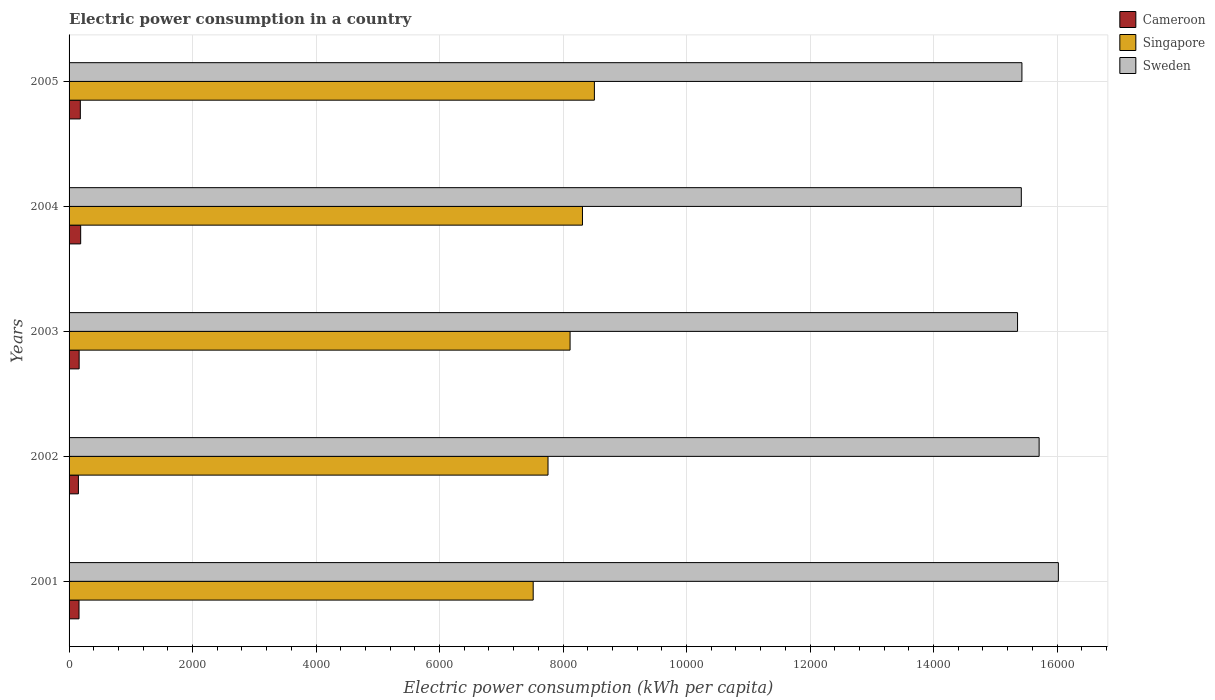Are the number of bars on each tick of the Y-axis equal?
Keep it short and to the point. Yes. How many bars are there on the 3rd tick from the top?
Keep it short and to the point. 3. How many bars are there on the 3rd tick from the bottom?
Keep it short and to the point. 3. What is the label of the 4th group of bars from the top?
Your answer should be compact. 2002. What is the electric power consumption in in Singapore in 2002?
Provide a short and direct response. 7756.23. Across all years, what is the maximum electric power consumption in in Singapore?
Ensure brevity in your answer.  8507.2. Across all years, what is the minimum electric power consumption in in Cameroon?
Ensure brevity in your answer.  151.14. In which year was the electric power consumption in in Cameroon maximum?
Keep it short and to the point. 2004. In which year was the electric power consumption in in Cameroon minimum?
Keep it short and to the point. 2002. What is the total electric power consumption in in Cameroon in the graph?
Provide a succinct answer. 845.44. What is the difference between the electric power consumption in in Sweden in 2004 and that in 2005?
Ensure brevity in your answer.  -9.99. What is the difference between the electric power consumption in in Cameroon in 2001 and the electric power consumption in in Sweden in 2002?
Your answer should be very brief. -1.55e+04. What is the average electric power consumption in in Cameroon per year?
Ensure brevity in your answer.  169.09. In the year 2005, what is the difference between the electric power consumption in in Singapore and electric power consumption in in Sweden?
Ensure brevity in your answer.  -6923.77. In how many years, is the electric power consumption in in Singapore greater than 12000 kWh per capita?
Keep it short and to the point. 0. What is the ratio of the electric power consumption in in Cameroon in 2001 to that in 2005?
Give a very brief answer. 0.88. Is the electric power consumption in in Singapore in 2001 less than that in 2004?
Offer a very short reply. Yes. What is the difference between the highest and the second highest electric power consumption in in Singapore?
Ensure brevity in your answer.  192.94. What is the difference between the highest and the lowest electric power consumption in in Sweden?
Your answer should be compact. 660.8. In how many years, is the electric power consumption in in Singapore greater than the average electric power consumption in in Singapore taken over all years?
Make the answer very short. 3. Is the sum of the electric power consumption in in Sweden in 2002 and 2005 greater than the maximum electric power consumption in in Singapore across all years?
Your answer should be compact. Yes. What does the 2nd bar from the top in 2001 represents?
Your response must be concise. Singapore. What does the 1st bar from the bottom in 2004 represents?
Offer a very short reply. Cameroon. Are all the bars in the graph horizontal?
Provide a short and direct response. Yes. How many years are there in the graph?
Keep it short and to the point. 5. What is the difference between two consecutive major ticks on the X-axis?
Make the answer very short. 2000. Are the values on the major ticks of X-axis written in scientific E-notation?
Offer a very short reply. No. Does the graph contain grids?
Your response must be concise. Yes. What is the title of the graph?
Ensure brevity in your answer.  Electric power consumption in a country. What is the label or title of the X-axis?
Keep it short and to the point. Electric power consumption (kWh per capita). What is the label or title of the Y-axis?
Your response must be concise. Years. What is the Electric power consumption (kWh per capita) in Cameroon in 2001?
Your response must be concise. 160.92. What is the Electric power consumption (kWh per capita) in Singapore in 2001?
Your answer should be compact. 7516.19. What is the Electric power consumption (kWh per capita) in Sweden in 2001?
Provide a succinct answer. 1.60e+04. What is the Electric power consumption (kWh per capita) of Cameroon in 2002?
Give a very brief answer. 151.14. What is the Electric power consumption (kWh per capita) of Singapore in 2002?
Offer a terse response. 7756.23. What is the Electric power consumption (kWh per capita) of Sweden in 2002?
Ensure brevity in your answer.  1.57e+04. What is the Electric power consumption (kWh per capita) of Cameroon in 2003?
Your answer should be compact. 163.08. What is the Electric power consumption (kWh per capita) of Singapore in 2003?
Provide a short and direct response. 8113.64. What is the Electric power consumption (kWh per capita) in Sweden in 2003?
Your answer should be compact. 1.54e+04. What is the Electric power consumption (kWh per capita) of Cameroon in 2004?
Give a very brief answer. 187.91. What is the Electric power consumption (kWh per capita) in Singapore in 2004?
Keep it short and to the point. 8314.25. What is the Electric power consumption (kWh per capita) of Sweden in 2004?
Your answer should be very brief. 1.54e+04. What is the Electric power consumption (kWh per capita) in Cameroon in 2005?
Provide a short and direct response. 182.38. What is the Electric power consumption (kWh per capita) in Singapore in 2005?
Your response must be concise. 8507.2. What is the Electric power consumption (kWh per capita) of Sweden in 2005?
Provide a short and direct response. 1.54e+04. Across all years, what is the maximum Electric power consumption (kWh per capita) of Cameroon?
Your response must be concise. 187.91. Across all years, what is the maximum Electric power consumption (kWh per capita) of Singapore?
Your answer should be very brief. 8507.2. Across all years, what is the maximum Electric power consumption (kWh per capita) in Sweden?
Provide a short and direct response. 1.60e+04. Across all years, what is the minimum Electric power consumption (kWh per capita) of Cameroon?
Make the answer very short. 151.14. Across all years, what is the minimum Electric power consumption (kWh per capita) in Singapore?
Keep it short and to the point. 7516.19. Across all years, what is the minimum Electric power consumption (kWh per capita) in Sweden?
Give a very brief answer. 1.54e+04. What is the total Electric power consumption (kWh per capita) in Cameroon in the graph?
Your answer should be compact. 845.44. What is the total Electric power consumption (kWh per capita) of Singapore in the graph?
Give a very brief answer. 4.02e+04. What is the total Electric power consumption (kWh per capita) of Sweden in the graph?
Offer a terse response. 7.79e+04. What is the difference between the Electric power consumption (kWh per capita) of Cameroon in 2001 and that in 2002?
Provide a succinct answer. 9.79. What is the difference between the Electric power consumption (kWh per capita) of Singapore in 2001 and that in 2002?
Your answer should be very brief. -240.03. What is the difference between the Electric power consumption (kWh per capita) in Sweden in 2001 and that in 2002?
Your answer should be very brief. 311.55. What is the difference between the Electric power consumption (kWh per capita) of Cameroon in 2001 and that in 2003?
Make the answer very short. -2.16. What is the difference between the Electric power consumption (kWh per capita) of Singapore in 2001 and that in 2003?
Offer a terse response. -597.45. What is the difference between the Electric power consumption (kWh per capita) of Sweden in 2001 and that in 2003?
Make the answer very short. 660.8. What is the difference between the Electric power consumption (kWh per capita) in Cameroon in 2001 and that in 2004?
Offer a very short reply. -26.99. What is the difference between the Electric power consumption (kWh per capita) in Singapore in 2001 and that in 2004?
Provide a short and direct response. -798.06. What is the difference between the Electric power consumption (kWh per capita) of Sweden in 2001 and that in 2004?
Give a very brief answer. 600.01. What is the difference between the Electric power consumption (kWh per capita) of Cameroon in 2001 and that in 2005?
Offer a very short reply. -21.46. What is the difference between the Electric power consumption (kWh per capita) of Singapore in 2001 and that in 2005?
Keep it short and to the point. -991.01. What is the difference between the Electric power consumption (kWh per capita) of Sweden in 2001 and that in 2005?
Provide a succinct answer. 590.02. What is the difference between the Electric power consumption (kWh per capita) of Cameroon in 2002 and that in 2003?
Your answer should be very brief. -11.94. What is the difference between the Electric power consumption (kWh per capita) in Singapore in 2002 and that in 2003?
Provide a succinct answer. -357.41. What is the difference between the Electric power consumption (kWh per capita) in Sweden in 2002 and that in 2003?
Your answer should be compact. 349.25. What is the difference between the Electric power consumption (kWh per capita) in Cameroon in 2002 and that in 2004?
Offer a terse response. -36.78. What is the difference between the Electric power consumption (kWh per capita) in Singapore in 2002 and that in 2004?
Give a very brief answer. -558.03. What is the difference between the Electric power consumption (kWh per capita) in Sweden in 2002 and that in 2004?
Your response must be concise. 288.46. What is the difference between the Electric power consumption (kWh per capita) in Cameroon in 2002 and that in 2005?
Keep it short and to the point. -31.24. What is the difference between the Electric power consumption (kWh per capita) in Singapore in 2002 and that in 2005?
Your answer should be compact. -750.97. What is the difference between the Electric power consumption (kWh per capita) in Sweden in 2002 and that in 2005?
Give a very brief answer. 278.47. What is the difference between the Electric power consumption (kWh per capita) in Cameroon in 2003 and that in 2004?
Your response must be concise. -24.84. What is the difference between the Electric power consumption (kWh per capita) of Singapore in 2003 and that in 2004?
Your answer should be very brief. -200.61. What is the difference between the Electric power consumption (kWh per capita) in Sweden in 2003 and that in 2004?
Your response must be concise. -60.79. What is the difference between the Electric power consumption (kWh per capita) in Cameroon in 2003 and that in 2005?
Provide a short and direct response. -19.3. What is the difference between the Electric power consumption (kWh per capita) of Singapore in 2003 and that in 2005?
Give a very brief answer. -393.56. What is the difference between the Electric power consumption (kWh per capita) of Sweden in 2003 and that in 2005?
Your answer should be compact. -70.79. What is the difference between the Electric power consumption (kWh per capita) in Cameroon in 2004 and that in 2005?
Ensure brevity in your answer.  5.54. What is the difference between the Electric power consumption (kWh per capita) in Singapore in 2004 and that in 2005?
Give a very brief answer. -192.94. What is the difference between the Electric power consumption (kWh per capita) in Sweden in 2004 and that in 2005?
Provide a short and direct response. -9.99. What is the difference between the Electric power consumption (kWh per capita) of Cameroon in 2001 and the Electric power consumption (kWh per capita) of Singapore in 2002?
Provide a short and direct response. -7595.3. What is the difference between the Electric power consumption (kWh per capita) of Cameroon in 2001 and the Electric power consumption (kWh per capita) of Sweden in 2002?
Your answer should be compact. -1.55e+04. What is the difference between the Electric power consumption (kWh per capita) in Singapore in 2001 and the Electric power consumption (kWh per capita) in Sweden in 2002?
Provide a short and direct response. -8193.24. What is the difference between the Electric power consumption (kWh per capita) of Cameroon in 2001 and the Electric power consumption (kWh per capita) of Singapore in 2003?
Your response must be concise. -7952.71. What is the difference between the Electric power consumption (kWh per capita) in Cameroon in 2001 and the Electric power consumption (kWh per capita) in Sweden in 2003?
Give a very brief answer. -1.52e+04. What is the difference between the Electric power consumption (kWh per capita) in Singapore in 2001 and the Electric power consumption (kWh per capita) in Sweden in 2003?
Offer a terse response. -7843.99. What is the difference between the Electric power consumption (kWh per capita) of Cameroon in 2001 and the Electric power consumption (kWh per capita) of Singapore in 2004?
Give a very brief answer. -8153.33. What is the difference between the Electric power consumption (kWh per capita) of Cameroon in 2001 and the Electric power consumption (kWh per capita) of Sweden in 2004?
Give a very brief answer. -1.53e+04. What is the difference between the Electric power consumption (kWh per capita) of Singapore in 2001 and the Electric power consumption (kWh per capita) of Sweden in 2004?
Give a very brief answer. -7904.78. What is the difference between the Electric power consumption (kWh per capita) in Cameroon in 2001 and the Electric power consumption (kWh per capita) in Singapore in 2005?
Keep it short and to the point. -8346.27. What is the difference between the Electric power consumption (kWh per capita) in Cameroon in 2001 and the Electric power consumption (kWh per capita) in Sweden in 2005?
Make the answer very short. -1.53e+04. What is the difference between the Electric power consumption (kWh per capita) of Singapore in 2001 and the Electric power consumption (kWh per capita) of Sweden in 2005?
Your answer should be very brief. -7914.77. What is the difference between the Electric power consumption (kWh per capita) of Cameroon in 2002 and the Electric power consumption (kWh per capita) of Singapore in 2003?
Provide a succinct answer. -7962.5. What is the difference between the Electric power consumption (kWh per capita) in Cameroon in 2002 and the Electric power consumption (kWh per capita) in Sweden in 2003?
Provide a succinct answer. -1.52e+04. What is the difference between the Electric power consumption (kWh per capita) of Singapore in 2002 and the Electric power consumption (kWh per capita) of Sweden in 2003?
Give a very brief answer. -7603.95. What is the difference between the Electric power consumption (kWh per capita) in Cameroon in 2002 and the Electric power consumption (kWh per capita) in Singapore in 2004?
Make the answer very short. -8163.12. What is the difference between the Electric power consumption (kWh per capita) of Cameroon in 2002 and the Electric power consumption (kWh per capita) of Sweden in 2004?
Offer a very short reply. -1.53e+04. What is the difference between the Electric power consumption (kWh per capita) in Singapore in 2002 and the Electric power consumption (kWh per capita) in Sweden in 2004?
Your response must be concise. -7664.75. What is the difference between the Electric power consumption (kWh per capita) of Cameroon in 2002 and the Electric power consumption (kWh per capita) of Singapore in 2005?
Your answer should be very brief. -8356.06. What is the difference between the Electric power consumption (kWh per capita) of Cameroon in 2002 and the Electric power consumption (kWh per capita) of Sweden in 2005?
Offer a very short reply. -1.53e+04. What is the difference between the Electric power consumption (kWh per capita) of Singapore in 2002 and the Electric power consumption (kWh per capita) of Sweden in 2005?
Give a very brief answer. -7674.74. What is the difference between the Electric power consumption (kWh per capita) of Cameroon in 2003 and the Electric power consumption (kWh per capita) of Singapore in 2004?
Your answer should be very brief. -8151.17. What is the difference between the Electric power consumption (kWh per capita) in Cameroon in 2003 and the Electric power consumption (kWh per capita) in Sweden in 2004?
Your response must be concise. -1.53e+04. What is the difference between the Electric power consumption (kWh per capita) of Singapore in 2003 and the Electric power consumption (kWh per capita) of Sweden in 2004?
Offer a very short reply. -7307.33. What is the difference between the Electric power consumption (kWh per capita) in Cameroon in 2003 and the Electric power consumption (kWh per capita) in Singapore in 2005?
Your response must be concise. -8344.12. What is the difference between the Electric power consumption (kWh per capita) of Cameroon in 2003 and the Electric power consumption (kWh per capita) of Sweden in 2005?
Ensure brevity in your answer.  -1.53e+04. What is the difference between the Electric power consumption (kWh per capita) in Singapore in 2003 and the Electric power consumption (kWh per capita) in Sweden in 2005?
Offer a terse response. -7317.33. What is the difference between the Electric power consumption (kWh per capita) of Cameroon in 2004 and the Electric power consumption (kWh per capita) of Singapore in 2005?
Keep it short and to the point. -8319.28. What is the difference between the Electric power consumption (kWh per capita) in Cameroon in 2004 and the Electric power consumption (kWh per capita) in Sweden in 2005?
Provide a short and direct response. -1.52e+04. What is the difference between the Electric power consumption (kWh per capita) of Singapore in 2004 and the Electric power consumption (kWh per capita) of Sweden in 2005?
Keep it short and to the point. -7116.71. What is the average Electric power consumption (kWh per capita) of Cameroon per year?
Provide a short and direct response. 169.09. What is the average Electric power consumption (kWh per capita) in Singapore per year?
Give a very brief answer. 8041.5. What is the average Electric power consumption (kWh per capita) of Sweden per year?
Provide a succinct answer. 1.56e+04. In the year 2001, what is the difference between the Electric power consumption (kWh per capita) of Cameroon and Electric power consumption (kWh per capita) of Singapore?
Provide a succinct answer. -7355.27. In the year 2001, what is the difference between the Electric power consumption (kWh per capita) in Cameroon and Electric power consumption (kWh per capita) in Sweden?
Provide a succinct answer. -1.59e+04. In the year 2001, what is the difference between the Electric power consumption (kWh per capita) of Singapore and Electric power consumption (kWh per capita) of Sweden?
Give a very brief answer. -8504.79. In the year 2002, what is the difference between the Electric power consumption (kWh per capita) of Cameroon and Electric power consumption (kWh per capita) of Singapore?
Your answer should be very brief. -7605.09. In the year 2002, what is the difference between the Electric power consumption (kWh per capita) in Cameroon and Electric power consumption (kWh per capita) in Sweden?
Give a very brief answer. -1.56e+04. In the year 2002, what is the difference between the Electric power consumption (kWh per capita) of Singapore and Electric power consumption (kWh per capita) of Sweden?
Your answer should be very brief. -7953.2. In the year 2003, what is the difference between the Electric power consumption (kWh per capita) in Cameroon and Electric power consumption (kWh per capita) in Singapore?
Your answer should be compact. -7950.56. In the year 2003, what is the difference between the Electric power consumption (kWh per capita) of Cameroon and Electric power consumption (kWh per capita) of Sweden?
Your answer should be very brief. -1.52e+04. In the year 2003, what is the difference between the Electric power consumption (kWh per capita) in Singapore and Electric power consumption (kWh per capita) in Sweden?
Provide a succinct answer. -7246.54. In the year 2004, what is the difference between the Electric power consumption (kWh per capita) in Cameroon and Electric power consumption (kWh per capita) in Singapore?
Keep it short and to the point. -8126.34. In the year 2004, what is the difference between the Electric power consumption (kWh per capita) of Cameroon and Electric power consumption (kWh per capita) of Sweden?
Make the answer very short. -1.52e+04. In the year 2004, what is the difference between the Electric power consumption (kWh per capita) in Singapore and Electric power consumption (kWh per capita) in Sweden?
Keep it short and to the point. -7106.72. In the year 2005, what is the difference between the Electric power consumption (kWh per capita) in Cameroon and Electric power consumption (kWh per capita) in Singapore?
Offer a terse response. -8324.82. In the year 2005, what is the difference between the Electric power consumption (kWh per capita) in Cameroon and Electric power consumption (kWh per capita) in Sweden?
Keep it short and to the point. -1.52e+04. In the year 2005, what is the difference between the Electric power consumption (kWh per capita) of Singapore and Electric power consumption (kWh per capita) of Sweden?
Offer a terse response. -6923.77. What is the ratio of the Electric power consumption (kWh per capita) in Cameroon in 2001 to that in 2002?
Give a very brief answer. 1.06. What is the ratio of the Electric power consumption (kWh per capita) in Singapore in 2001 to that in 2002?
Provide a short and direct response. 0.97. What is the ratio of the Electric power consumption (kWh per capita) of Sweden in 2001 to that in 2002?
Offer a terse response. 1.02. What is the ratio of the Electric power consumption (kWh per capita) in Singapore in 2001 to that in 2003?
Keep it short and to the point. 0.93. What is the ratio of the Electric power consumption (kWh per capita) in Sweden in 2001 to that in 2003?
Offer a terse response. 1.04. What is the ratio of the Electric power consumption (kWh per capita) in Cameroon in 2001 to that in 2004?
Provide a short and direct response. 0.86. What is the ratio of the Electric power consumption (kWh per capita) of Singapore in 2001 to that in 2004?
Your answer should be very brief. 0.9. What is the ratio of the Electric power consumption (kWh per capita) in Sweden in 2001 to that in 2004?
Offer a very short reply. 1.04. What is the ratio of the Electric power consumption (kWh per capita) in Cameroon in 2001 to that in 2005?
Ensure brevity in your answer.  0.88. What is the ratio of the Electric power consumption (kWh per capita) in Singapore in 2001 to that in 2005?
Your answer should be compact. 0.88. What is the ratio of the Electric power consumption (kWh per capita) of Sweden in 2001 to that in 2005?
Ensure brevity in your answer.  1.04. What is the ratio of the Electric power consumption (kWh per capita) of Cameroon in 2002 to that in 2003?
Offer a terse response. 0.93. What is the ratio of the Electric power consumption (kWh per capita) in Singapore in 2002 to that in 2003?
Ensure brevity in your answer.  0.96. What is the ratio of the Electric power consumption (kWh per capita) in Sweden in 2002 to that in 2003?
Ensure brevity in your answer.  1.02. What is the ratio of the Electric power consumption (kWh per capita) of Cameroon in 2002 to that in 2004?
Offer a very short reply. 0.8. What is the ratio of the Electric power consumption (kWh per capita) in Singapore in 2002 to that in 2004?
Offer a terse response. 0.93. What is the ratio of the Electric power consumption (kWh per capita) of Sweden in 2002 to that in 2004?
Your answer should be compact. 1.02. What is the ratio of the Electric power consumption (kWh per capita) in Cameroon in 2002 to that in 2005?
Offer a very short reply. 0.83. What is the ratio of the Electric power consumption (kWh per capita) of Singapore in 2002 to that in 2005?
Give a very brief answer. 0.91. What is the ratio of the Electric power consumption (kWh per capita) of Sweden in 2002 to that in 2005?
Offer a terse response. 1.02. What is the ratio of the Electric power consumption (kWh per capita) of Cameroon in 2003 to that in 2004?
Your response must be concise. 0.87. What is the ratio of the Electric power consumption (kWh per capita) of Singapore in 2003 to that in 2004?
Make the answer very short. 0.98. What is the ratio of the Electric power consumption (kWh per capita) of Sweden in 2003 to that in 2004?
Your answer should be very brief. 1. What is the ratio of the Electric power consumption (kWh per capita) in Cameroon in 2003 to that in 2005?
Keep it short and to the point. 0.89. What is the ratio of the Electric power consumption (kWh per capita) in Singapore in 2003 to that in 2005?
Your response must be concise. 0.95. What is the ratio of the Electric power consumption (kWh per capita) in Cameroon in 2004 to that in 2005?
Your response must be concise. 1.03. What is the ratio of the Electric power consumption (kWh per capita) of Singapore in 2004 to that in 2005?
Your answer should be very brief. 0.98. What is the difference between the highest and the second highest Electric power consumption (kWh per capita) in Cameroon?
Ensure brevity in your answer.  5.54. What is the difference between the highest and the second highest Electric power consumption (kWh per capita) of Singapore?
Provide a succinct answer. 192.94. What is the difference between the highest and the second highest Electric power consumption (kWh per capita) of Sweden?
Keep it short and to the point. 311.55. What is the difference between the highest and the lowest Electric power consumption (kWh per capita) in Cameroon?
Offer a terse response. 36.78. What is the difference between the highest and the lowest Electric power consumption (kWh per capita) of Singapore?
Your answer should be very brief. 991.01. What is the difference between the highest and the lowest Electric power consumption (kWh per capita) of Sweden?
Your answer should be compact. 660.8. 